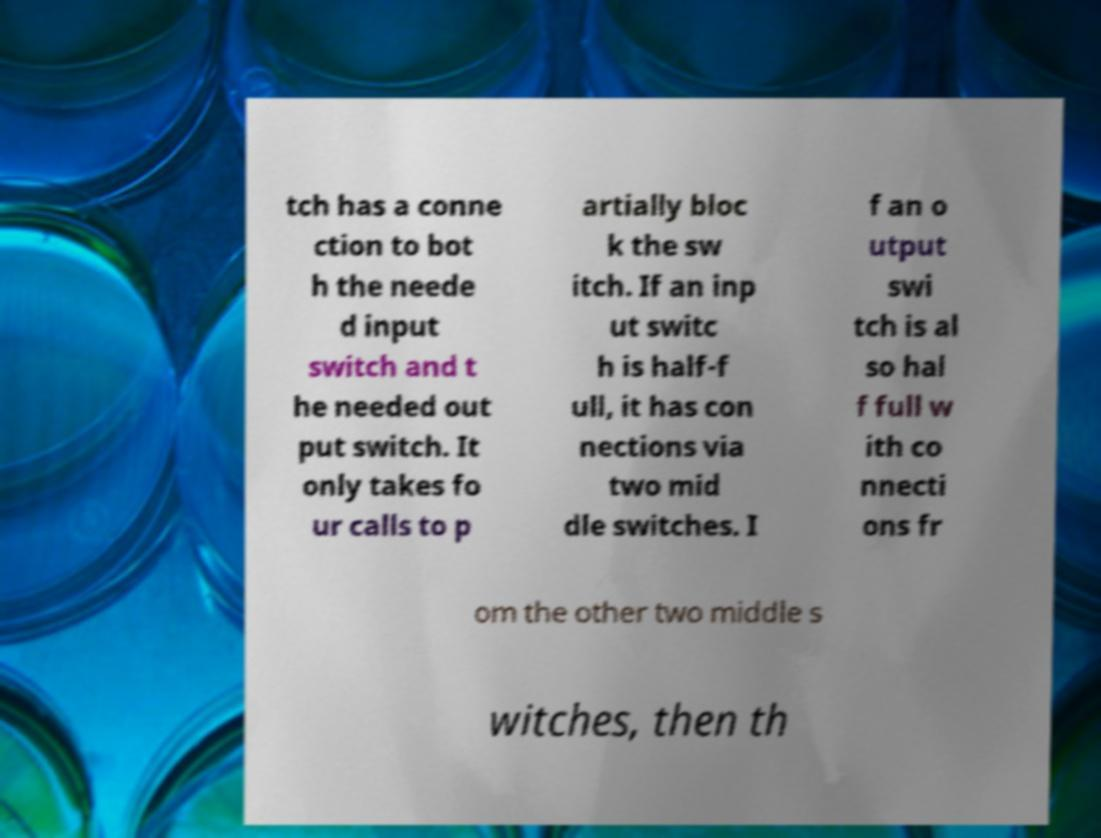Can you accurately transcribe the text from the provided image for me? tch has a conne ction to bot h the neede d input switch and t he needed out put switch. It only takes fo ur calls to p artially bloc k the sw itch. If an inp ut switc h is half-f ull, it has con nections via two mid dle switches. I f an o utput swi tch is al so hal f full w ith co nnecti ons fr om the other two middle s witches, then th 